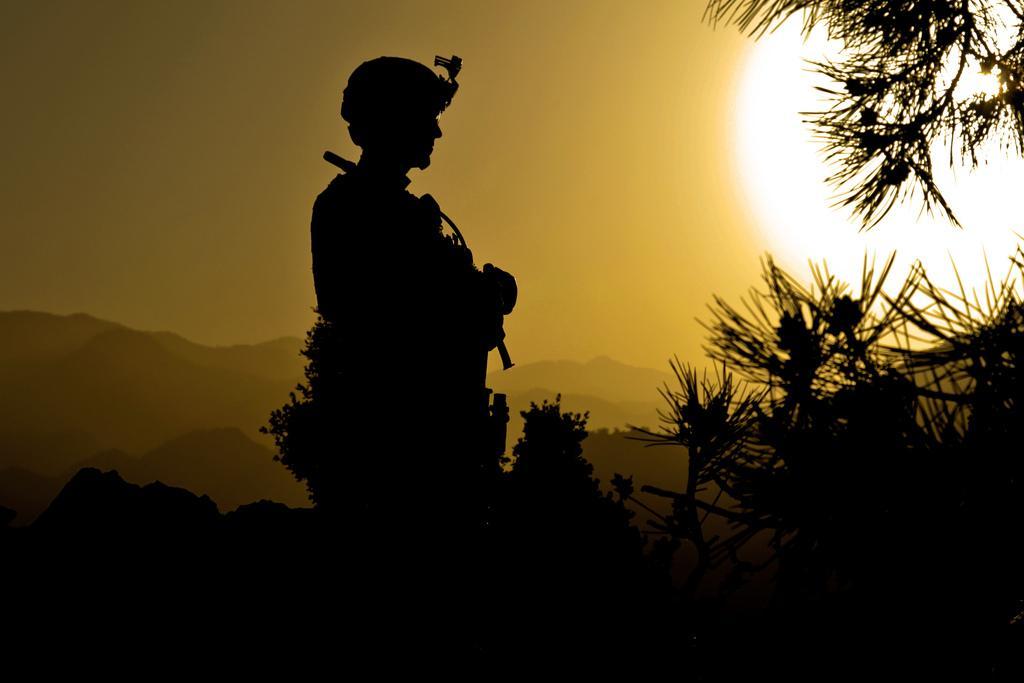Could you give a brief overview of what you see in this image? This picture is taken during night and there are trees and light visible on the right side , in the middle it might be look like a person sculpture and the hill and the sky. 